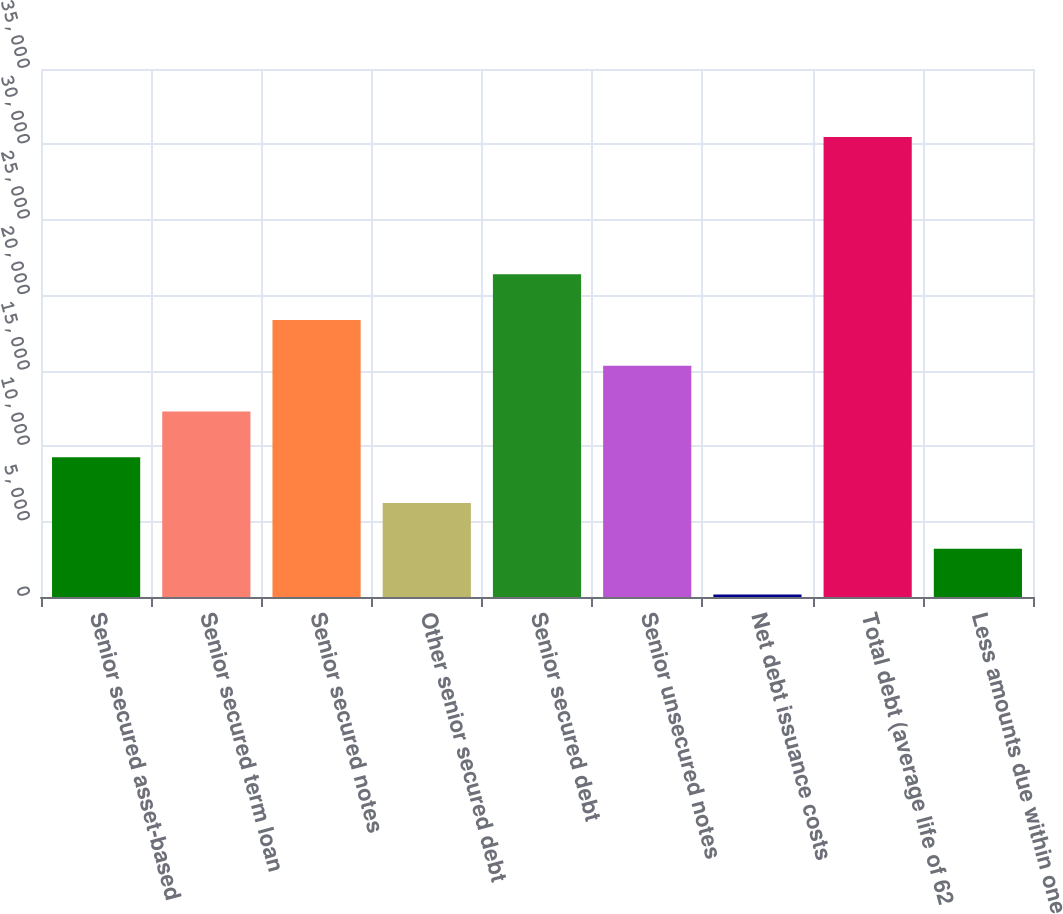Convert chart to OTSL. <chart><loc_0><loc_0><loc_500><loc_500><bar_chart><fcel>Senior secured asset-based<fcel>Senior secured term loan<fcel>Senior secured notes<fcel>Other senior secured debt<fcel>Senior secured debt<fcel>Senior unsecured notes<fcel>Net debt issuance costs<fcel>Total debt (average life of 62<fcel>Less amounts due within one<nl><fcel>9263.3<fcel>12295.4<fcel>18359.6<fcel>6231.2<fcel>21391.7<fcel>15327.5<fcel>167<fcel>30488<fcel>3199.1<nl></chart> 